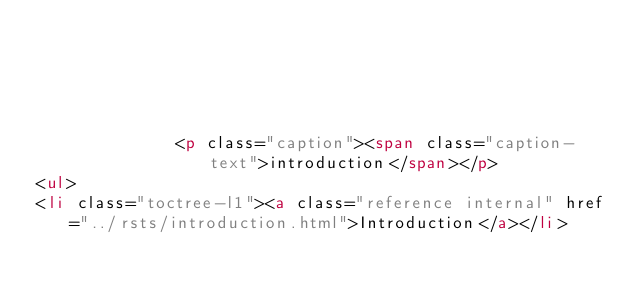Convert code to text. <code><loc_0><loc_0><loc_500><loc_500><_HTML_>            
            
              
            
            
              <p class="caption"><span class="caption-text">introduction</span></p>
<ul>
<li class="toctree-l1"><a class="reference internal" href="../rsts/introduction.html">Introduction</a></li></code> 